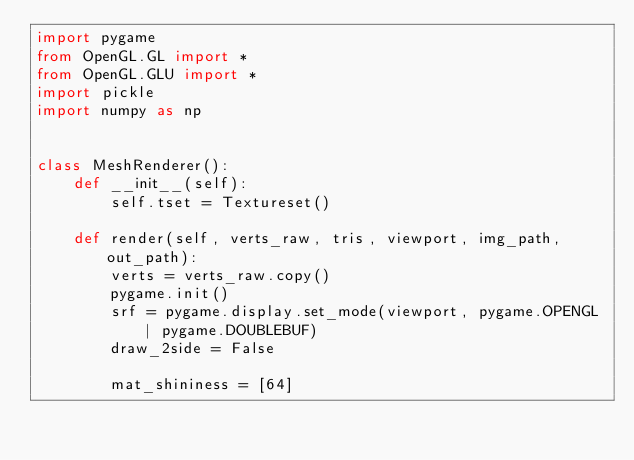Convert code to text. <code><loc_0><loc_0><loc_500><loc_500><_Python_>import pygame
from OpenGL.GL import *
from OpenGL.GLU import *
import pickle
import numpy as np


class MeshRenderer():
    def __init__(self):
        self.tset = Textureset()

    def render(self, verts_raw, tris, viewport, img_path, out_path):
        verts = verts_raw.copy()
        pygame.init()
        srf = pygame.display.set_mode(viewport, pygame.OPENGL | pygame.DOUBLEBUF)
        draw_2side = False

        mat_shininess = [64]</code> 